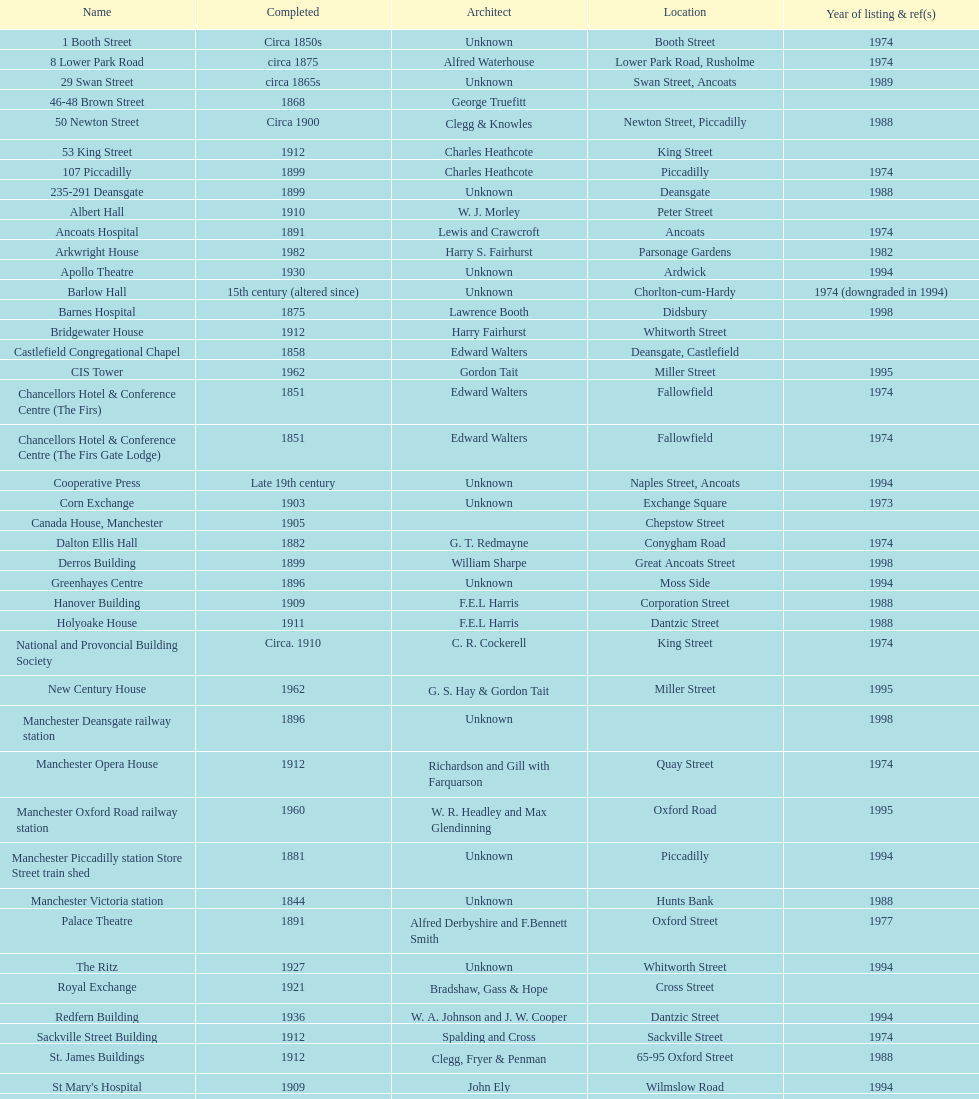What is the number of buildings listed in the year 1974? 15. 